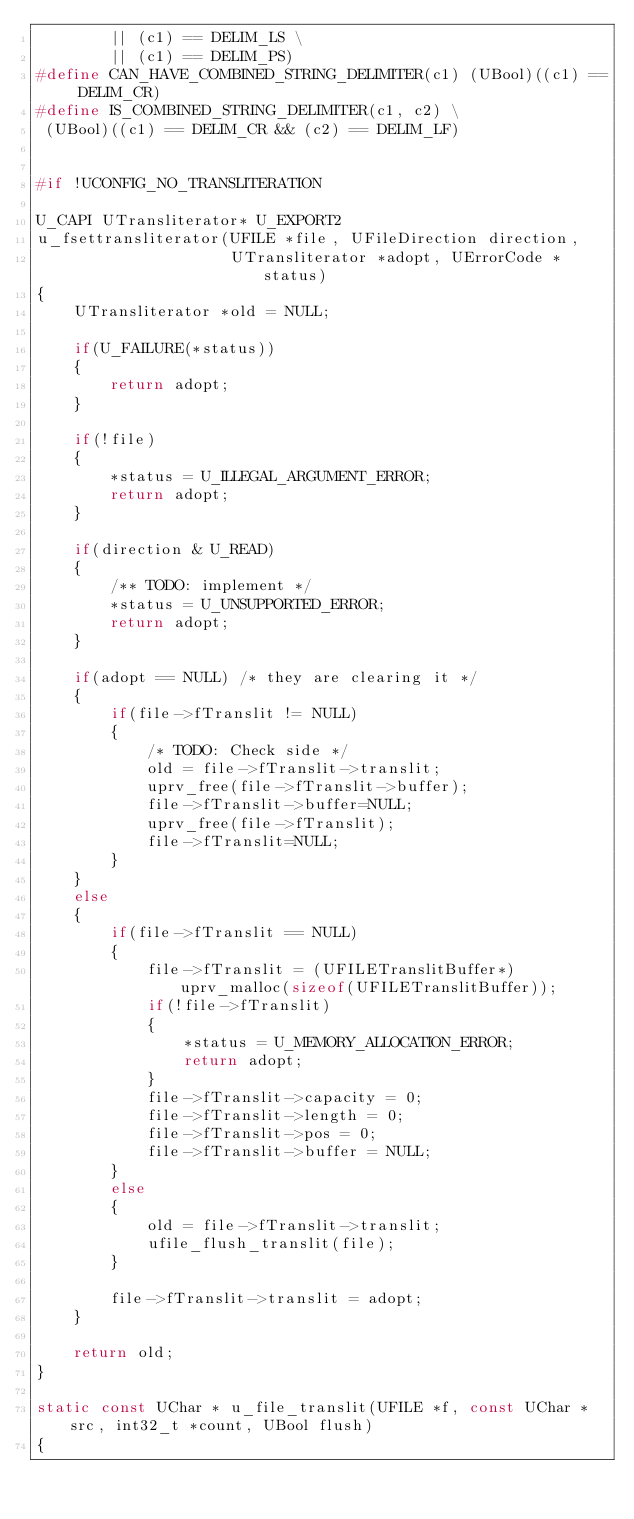<code> <loc_0><loc_0><loc_500><loc_500><_C++_>        || (c1) == DELIM_LS \
        || (c1) == DELIM_PS)
#define CAN_HAVE_COMBINED_STRING_DELIMITER(c1) (UBool)((c1) == DELIM_CR)
#define IS_COMBINED_STRING_DELIMITER(c1, c2) \
 (UBool)((c1) == DELIM_CR && (c2) == DELIM_LF)


#if !UCONFIG_NO_TRANSLITERATION

U_CAPI UTransliterator* U_EXPORT2
u_fsettransliterator(UFILE *file, UFileDirection direction,
                     UTransliterator *adopt, UErrorCode *status)
{
    UTransliterator *old = NULL;

    if(U_FAILURE(*status))
    {
        return adopt;
    }

    if(!file)
    {
        *status = U_ILLEGAL_ARGUMENT_ERROR;
        return adopt;
    }

    if(direction & U_READ)
    {
        /** TODO: implement */
        *status = U_UNSUPPORTED_ERROR;
        return adopt;
    }

    if(adopt == NULL) /* they are clearing it */
    {
        if(file->fTranslit != NULL)
        {
            /* TODO: Check side */
            old = file->fTranslit->translit;
            uprv_free(file->fTranslit->buffer);
            file->fTranslit->buffer=NULL;
            uprv_free(file->fTranslit);
            file->fTranslit=NULL;
        }
    }
    else
    {
        if(file->fTranslit == NULL)
        {
            file->fTranslit = (UFILETranslitBuffer*) uprv_malloc(sizeof(UFILETranslitBuffer));
            if(!file->fTranslit)
            {
                *status = U_MEMORY_ALLOCATION_ERROR;
                return adopt;
            }
            file->fTranslit->capacity = 0;
            file->fTranslit->length = 0;
            file->fTranslit->pos = 0;
            file->fTranslit->buffer = NULL;
        }
        else
        {
            old = file->fTranslit->translit;
            ufile_flush_translit(file);
        }

        file->fTranslit->translit = adopt;
    }

    return old;
}

static const UChar * u_file_translit(UFILE *f, const UChar *src, int32_t *count, UBool flush)
{</code> 